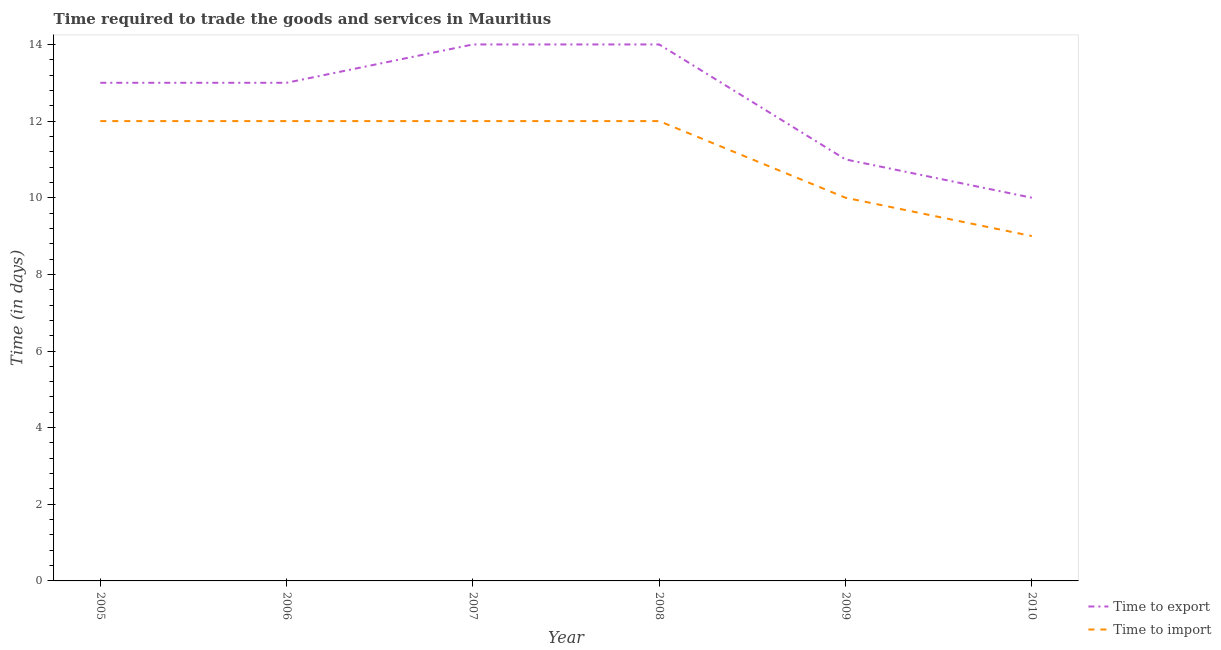Does the line corresponding to time to import intersect with the line corresponding to time to export?
Ensure brevity in your answer.  No. Is the number of lines equal to the number of legend labels?
Provide a short and direct response. Yes. What is the time to import in 2006?
Your answer should be compact. 12. Across all years, what is the maximum time to import?
Make the answer very short. 12. Across all years, what is the minimum time to import?
Make the answer very short. 9. In which year was the time to export minimum?
Offer a terse response. 2010. What is the total time to export in the graph?
Offer a very short reply. 75. What is the difference between the time to import in 2006 and that in 2007?
Your response must be concise. 0. What is the difference between the time to import in 2007 and the time to export in 2006?
Your response must be concise. -1. What is the average time to export per year?
Provide a short and direct response. 12.5. In the year 2006, what is the difference between the time to import and time to export?
Make the answer very short. -1. What is the ratio of the time to import in 2007 to that in 2010?
Offer a terse response. 1.33. What is the difference between the highest and the lowest time to import?
Keep it short and to the point. 3. In how many years, is the time to import greater than the average time to import taken over all years?
Offer a terse response. 4. Does the time to import monotonically increase over the years?
Make the answer very short. No. Is the time to export strictly less than the time to import over the years?
Offer a very short reply. No. What is the difference between two consecutive major ticks on the Y-axis?
Your answer should be compact. 2. Does the graph contain any zero values?
Provide a short and direct response. No. Does the graph contain grids?
Your response must be concise. No. What is the title of the graph?
Keep it short and to the point. Time required to trade the goods and services in Mauritius. What is the label or title of the X-axis?
Keep it short and to the point. Year. What is the label or title of the Y-axis?
Your answer should be very brief. Time (in days). What is the Time (in days) in Time to export in 2005?
Provide a succinct answer. 13. What is the Time (in days) in Time to import in 2005?
Make the answer very short. 12. What is the Time (in days) in Time to import in 2006?
Keep it short and to the point. 12. What is the Time (in days) of Time to import in 2007?
Ensure brevity in your answer.  12. What is the Time (in days) in Time to export in 2009?
Provide a succinct answer. 11. What is the Time (in days) in Time to export in 2010?
Your answer should be very brief. 10. What is the Time (in days) in Time to import in 2010?
Give a very brief answer. 9. Across all years, what is the maximum Time (in days) in Time to export?
Offer a terse response. 14. What is the total Time (in days) of Time to import in the graph?
Provide a short and direct response. 67. What is the difference between the Time (in days) of Time to export in 2005 and that in 2006?
Provide a succinct answer. 0. What is the difference between the Time (in days) of Time to import in 2005 and that in 2006?
Give a very brief answer. 0. What is the difference between the Time (in days) of Time to import in 2005 and that in 2007?
Your response must be concise. 0. What is the difference between the Time (in days) of Time to import in 2005 and that in 2008?
Ensure brevity in your answer.  0. What is the difference between the Time (in days) of Time to export in 2005 and that in 2009?
Offer a very short reply. 2. What is the difference between the Time (in days) in Time to import in 2005 and that in 2009?
Your answer should be very brief. 2. What is the difference between the Time (in days) of Time to export in 2006 and that in 2007?
Give a very brief answer. -1. What is the difference between the Time (in days) of Time to import in 2006 and that in 2008?
Provide a succinct answer. 0. What is the difference between the Time (in days) of Time to export in 2006 and that in 2009?
Keep it short and to the point. 2. What is the difference between the Time (in days) in Time to import in 2006 and that in 2009?
Offer a terse response. 2. What is the difference between the Time (in days) of Time to import in 2006 and that in 2010?
Your response must be concise. 3. What is the difference between the Time (in days) in Time to export in 2007 and that in 2008?
Provide a succinct answer. 0. What is the difference between the Time (in days) in Time to export in 2007 and that in 2010?
Provide a succinct answer. 4. What is the difference between the Time (in days) in Time to import in 2007 and that in 2010?
Give a very brief answer. 3. What is the difference between the Time (in days) of Time to export in 2008 and that in 2009?
Your response must be concise. 3. What is the difference between the Time (in days) in Time to import in 2009 and that in 2010?
Your answer should be very brief. 1. What is the difference between the Time (in days) of Time to export in 2005 and the Time (in days) of Time to import in 2007?
Give a very brief answer. 1. What is the difference between the Time (in days) of Time to export in 2006 and the Time (in days) of Time to import in 2008?
Make the answer very short. 1. What is the difference between the Time (in days) of Time to export in 2007 and the Time (in days) of Time to import in 2008?
Offer a terse response. 2. What is the difference between the Time (in days) in Time to export in 2007 and the Time (in days) in Time to import in 2010?
Keep it short and to the point. 5. What is the difference between the Time (in days) in Time to export in 2008 and the Time (in days) in Time to import in 2010?
Offer a terse response. 5. What is the difference between the Time (in days) in Time to export in 2009 and the Time (in days) in Time to import in 2010?
Make the answer very short. 2. What is the average Time (in days) of Time to import per year?
Provide a short and direct response. 11.17. In the year 2005, what is the difference between the Time (in days) of Time to export and Time (in days) of Time to import?
Provide a short and direct response. 1. In the year 2007, what is the difference between the Time (in days) of Time to export and Time (in days) of Time to import?
Keep it short and to the point. 2. In the year 2008, what is the difference between the Time (in days) in Time to export and Time (in days) in Time to import?
Give a very brief answer. 2. In the year 2010, what is the difference between the Time (in days) of Time to export and Time (in days) of Time to import?
Give a very brief answer. 1. What is the ratio of the Time (in days) in Time to export in 2005 to that in 2007?
Keep it short and to the point. 0.93. What is the ratio of the Time (in days) in Time to import in 2005 to that in 2008?
Offer a terse response. 1. What is the ratio of the Time (in days) of Time to export in 2005 to that in 2009?
Your answer should be very brief. 1.18. What is the ratio of the Time (in days) of Time to export in 2005 to that in 2010?
Keep it short and to the point. 1.3. What is the ratio of the Time (in days) of Time to import in 2005 to that in 2010?
Keep it short and to the point. 1.33. What is the ratio of the Time (in days) of Time to export in 2006 to that in 2007?
Offer a terse response. 0.93. What is the ratio of the Time (in days) of Time to import in 2006 to that in 2007?
Provide a succinct answer. 1. What is the ratio of the Time (in days) of Time to export in 2006 to that in 2008?
Keep it short and to the point. 0.93. What is the ratio of the Time (in days) of Time to export in 2006 to that in 2009?
Your answer should be compact. 1.18. What is the ratio of the Time (in days) of Time to import in 2006 to that in 2010?
Ensure brevity in your answer.  1.33. What is the ratio of the Time (in days) of Time to export in 2007 to that in 2009?
Your answer should be compact. 1.27. What is the ratio of the Time (in days) of Time to import in 2007 to that in 2009?
Make the answer very short. 1.2. What is the ratio of the Time (in days) in Time to export in 2007 to that in 2010?
Keep it short and to the point. 1.4. What is the ratio of the Time (in days) in Time to import in 2007 to that in 2010?
Your response must be concise. 1.33. What is the ratio of the Time (in days) of Time to export in 2008 to that in 2009?
Keep it short and to the point. 1.27. What is the ratio of the Time (in days) of Time to export in 2008 to that in 2010?
Provide a succinct answer. 1.4. What is the difference between the highest and the second highest Time (in days) in Time to import?
Provide a succinct answer. 0. 